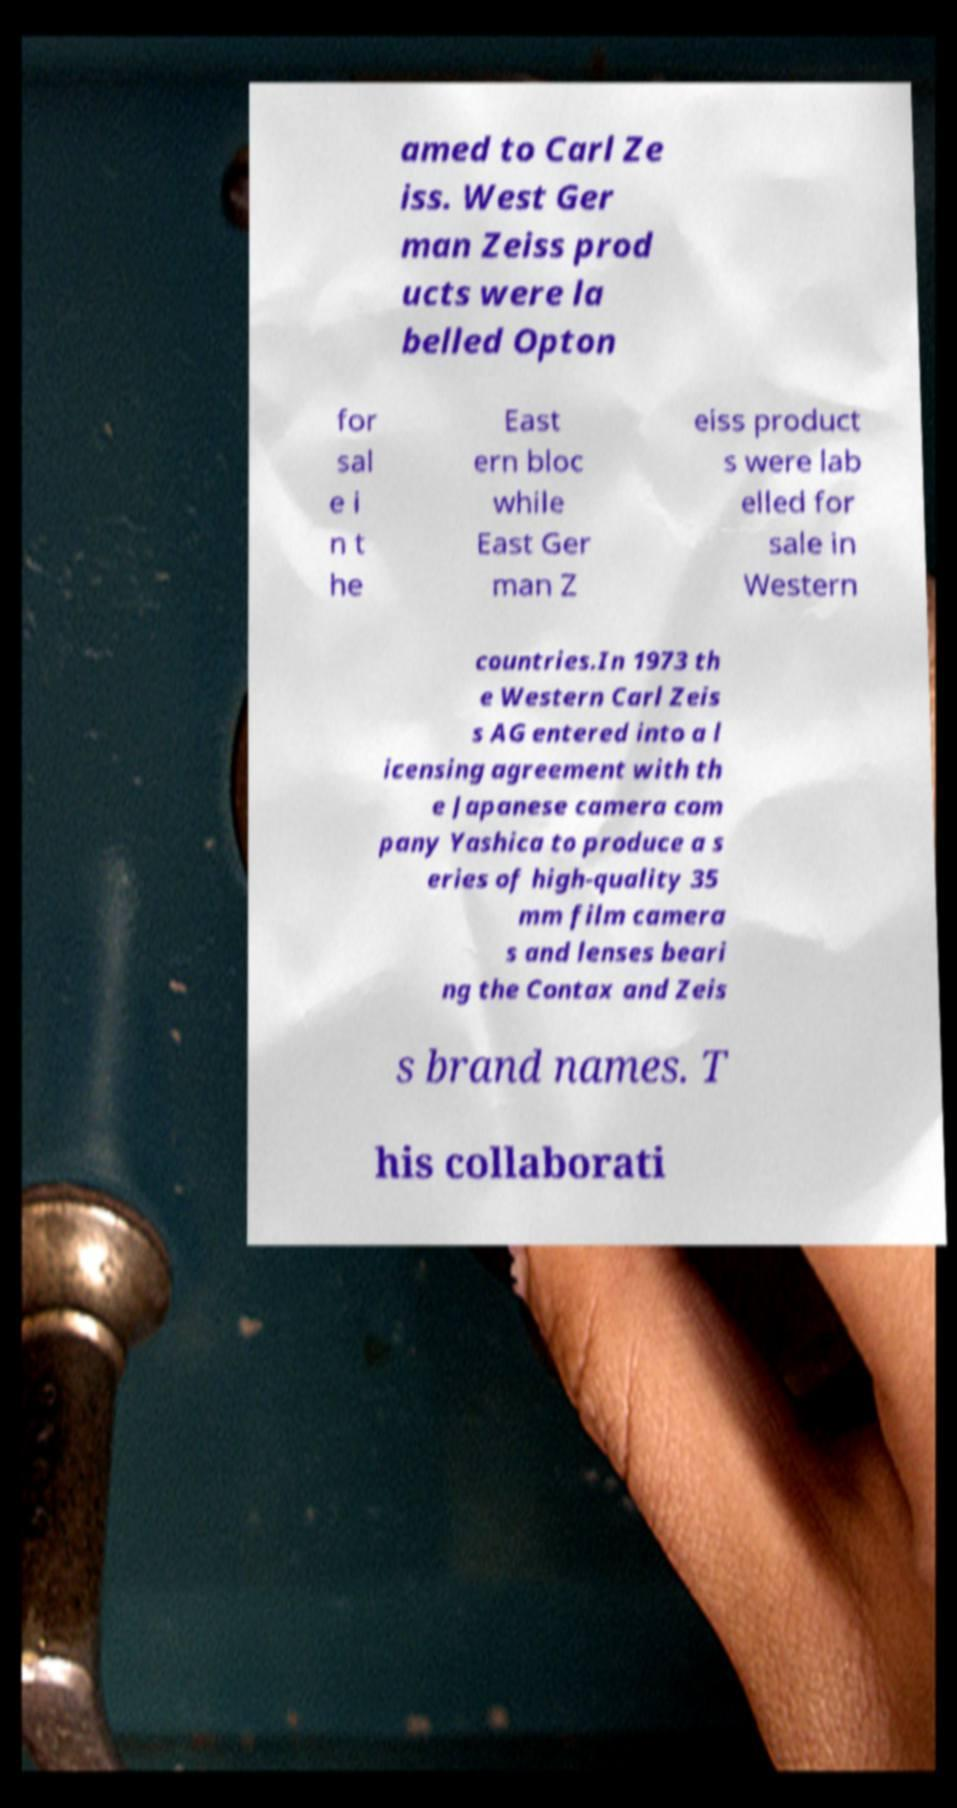Please read and relay the text visible in this image. What does it say? amed to Carl Ze iss. West Ger man Zeiss prod ucts were la belled Opton for sal e i n t he East ern bloc while East Ger man Z eiss product s were lab elled for sale in Western countries.In 1973 th e Western Carl Zeis s AG entered into a l icensing agreement with th e Japanese camera com pany Yashica to produce a s eries of high-quality 35 mm film camera s and lenses beari ng the Contax and Zeis s brand names. T his collaborati 